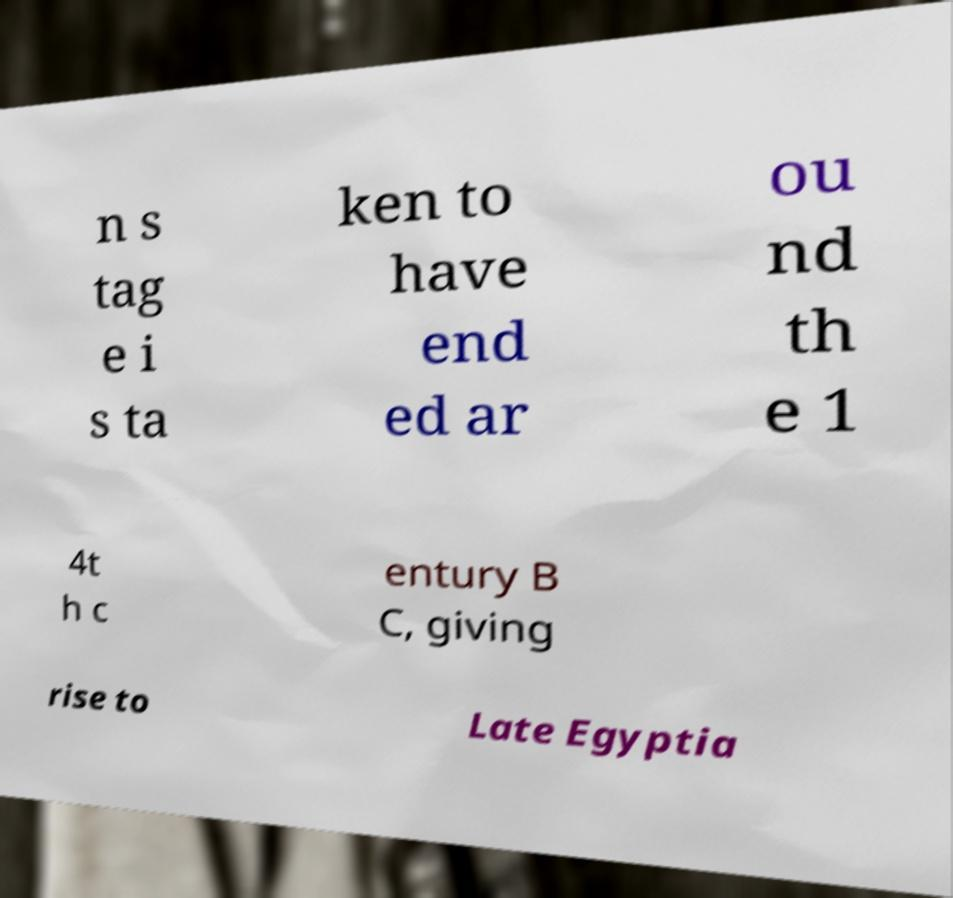Please identify and transcribe the text found in this image. n s tag e i s ta ken to have end ed ar ou nd th e 1 4t h c entury B C, giving rise to Late Egyptia 